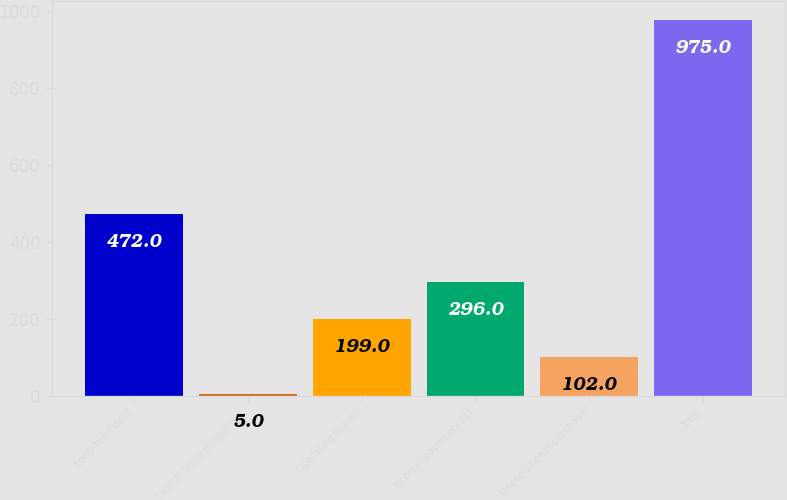Convert chart to OTSL. <chart><loc_0><loc_0><loc_500><loc_500><bar_chart><fcel>Long-term debt<fcel>Capital lease obligations<fcel>Operating leases<fcel>Interest payments (1)<fcel>Unconditional purchase<fcel>Total<nl><fcel>472<fcel>5<fcel>199<fcel>296<fcel>102<fcel>975<nl></chart> 